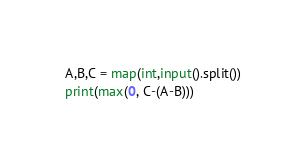Convert code to text. <code><loc_0><loc_0><loc_500><loc_500><_Python_>A,B,C = map(int,input().split())
print(max(0, C-(A-B)))
</code> 